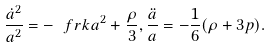<formula> <loc_0><loc_0><loc_500><loc_500>\frac { \dot { a } ^ { 2 } } { a ^ { 2 } } = - \ f r { k } { a ^ { 2 } } + \frac { \rho } { 3 } , \frac { \ddot { a } } { a } = - \frac { 1 } { 6 } ( \rho + 3 p ) .</formula> 